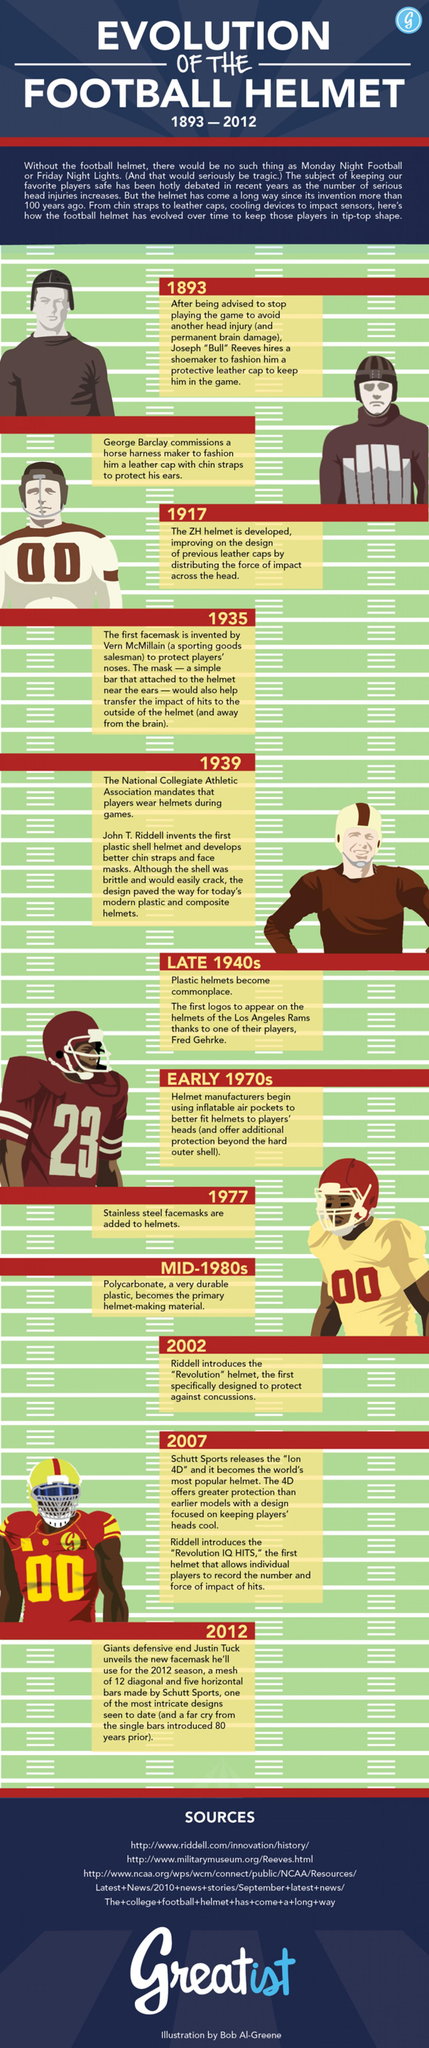Mention a couple of crucial points in this snapshot. There are three sources listed at the bottom. 